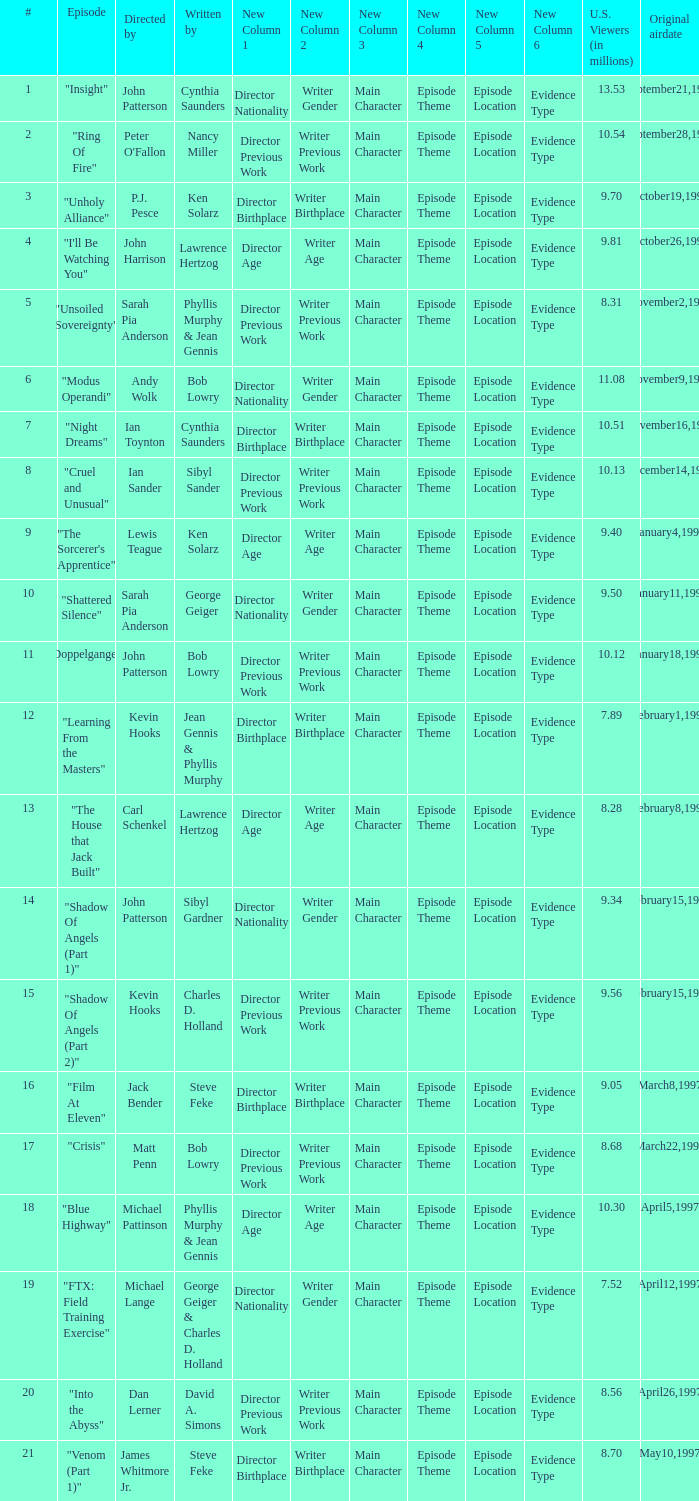Who wrote the episode with 7.52 million US viewers? George Geiger & Charles D. Holland. 